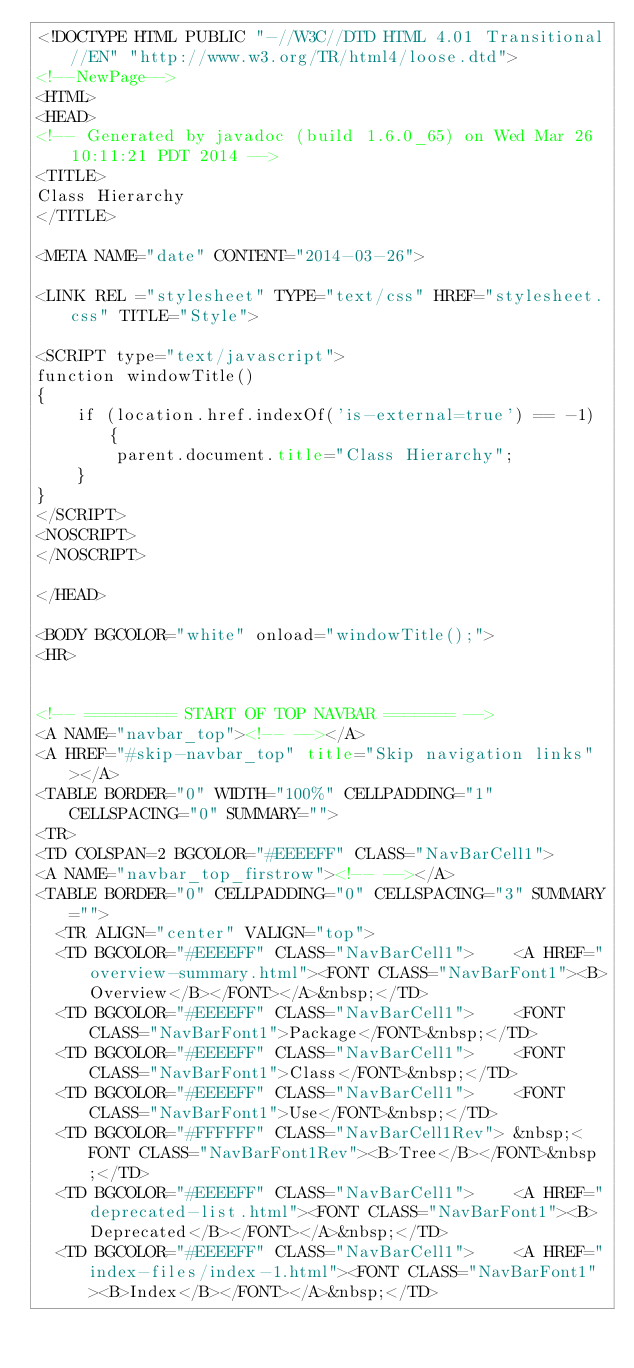Convert code to text. <code><loc_0><loc_0><loc_500><loc_500><_HTML_><!DOCTYPE HTML PUBLIC "-//W3C//DTD HTML 4.01 Transitional//EN" "http://www.w3.org/TR/html4/loose.dtd">
<!--NewPage-->
<HTML>
<HEAD>
<!-- Generated by javadoc (build 1.6.0_65) on Wed Mar 26 10:11:21 PDT 2014 -->
<TITLE>
Class Hierarchy
</TITLE>

<META NAME="date" CONTENT="2014-03-26">

<LINK REL ="stylesheet" TYPE="text/css" HREF="stylesheet.css" TITLE="Style">

<SCRIPT type="text/javascript">
function windowTitle()
{
    if (location.href.indexOf('is-external=true') == -1) {
        parent.document.title="Class Hierarchy";
    }
}
</SCRIPT>
<NOSCRIPT>
</NOSCRIPT>

</HEAD>

<BODY BGCOLOR="white" onload="windowTitle();">
<HR>


<!-- ========= START OF TOP NAVBAR ======= -->
<A NAME="navbar_top"><!-- --></A>
<A HREF="#skip-navbar_top" title="Skip navigation links"></A>
<TABLE BORDER="0" WIDTH="100%" CELLPADDING="1" CELLSPACING="0" SUMMARY="">
<TR>
<TD COLSPAN=2 BGCOLOR="#EEEEFF" CLASS="NavBarCell1">
<A NAME="navbar_top_firstrow"><!-- --></A>
<TABLE BORDER="0" CELLPADDING="0" CELLSPACING="3" SUMMARY="">
  <TR ALIGN="center" VALIGN="top">
  <TD BGCOLOR="#EEEEFF" CLASS="NavBarCell1">    <A HREF="overview-summary.html"><FONT CLASS="NavBarFont1"><B>Overview</B></FONT></A>&nbsp;</TD>
  <TD BGCOLOR="#EEEEFF" CLASS="NavBarCell1">    <FONT CLASS="NavBarFont1">Package</FONT>&nbsp;</TD>
  <TD BGCOLOR="#EEEEFF" CLASS="NavBarCell1">    <FONT CLASS="NavBarFont1">Class</FONT>&nbsp;</TD>
  <TD BGCOLOR="#EEEEFF" CLASS="NavBarCell1">    <FONT CLASS="NavBarFont1">Use</FONT>&nbsp;</TD>
  <TD BGCOLOR="#FFFFFF" CLASS="NavBarCell1Rev"> &nbsp;<FONT CLASS="NavBarFont1Rev"><B>Tree</B></FONT>&nbsp;</TD>
  <TD BGCOLOR="#EEEEFF" CLASS="NavBarCell1">    <A HREF="deprecated-list.html"><FONT CLASS="NavBarFont1"><B>Deprecated</B></FONT></A>&nbsp;</TD>
  <TD BGCOLOR="#EEEEFF" CLASS="NavBarCell1">    <A HREF="index-files/index-1.html"><FONT CLASS="NavBarFont1"><B>Index</B></FONT></A>&nbsp;</TD></code> 